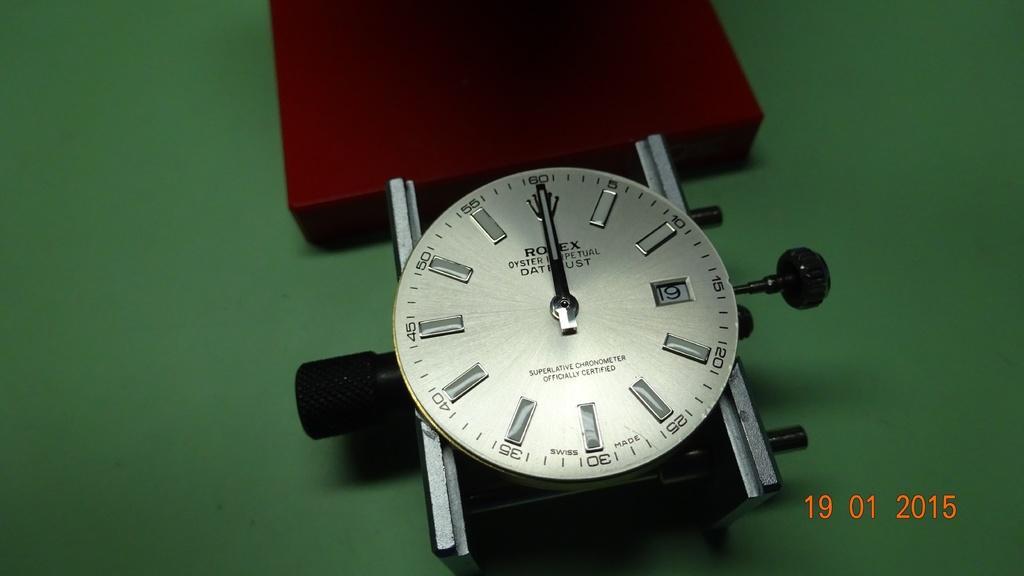How would you summarize this image in a sentence or two? In this image I can see the clock on the green color surface. To the side I can see the red color object. 